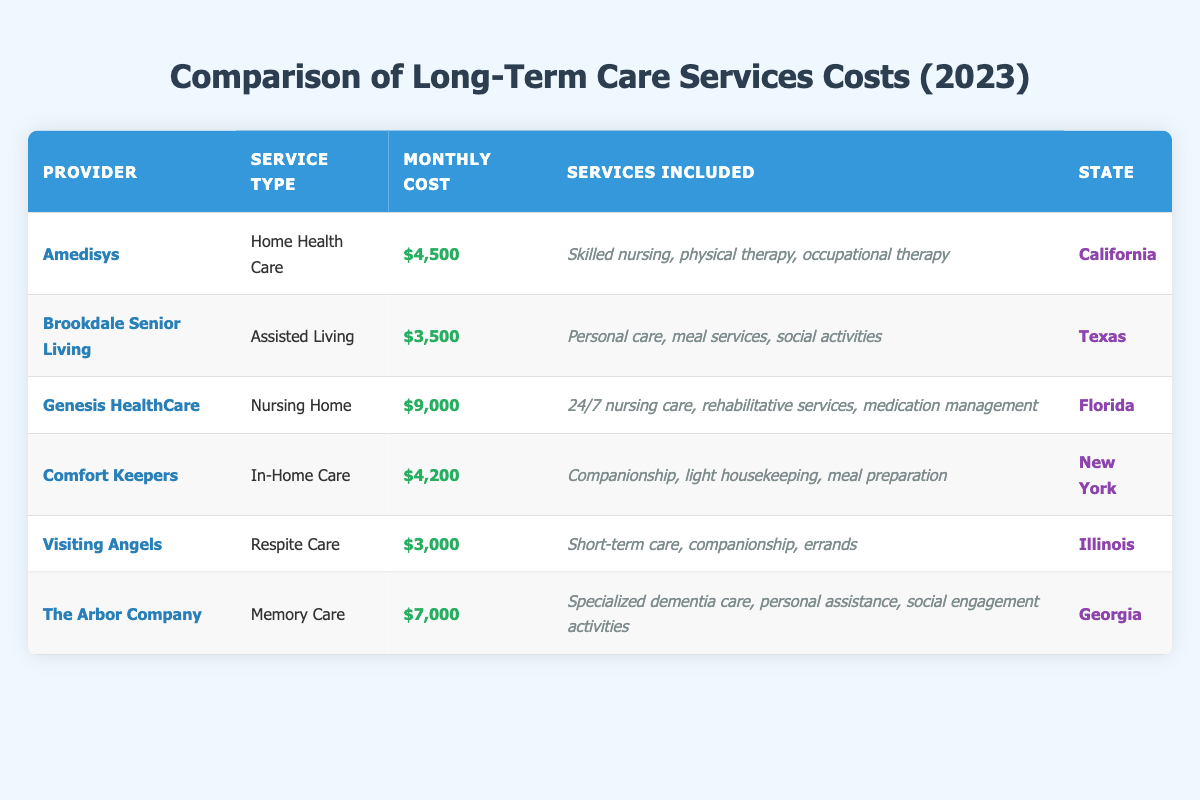What is the highest monthly cost for long-term care services among the providers listed? By reviewing the "Monthly Cost" column, we identify Genesis HealthCare, which has the highest cost of $9,000.
Answer: $9,000 Which provider offers Assisted Living services? According to the "Service Type" column, Brookdale Senior Living is listed as offering Assisted Living services.
Answer: Brookdale Senior Living What is the total monthly cost for In-Home Care and Home Health Care services? To find this, we first extract the costs: In-Home Care (Comfort Keepers) is $4,200 and Home Health Care (Amedisys) is $4,500. Adding these two amounts gives us a total of $4,200 + $4,500 = $8,700.
Answer: $8,700 Is there any provider that offers services in California? Looking at the "State" column, Amedisys offers Home Health Care services in California, confirming that there is a provider in that state.
Answer: Yes What is the average monthly cost of the long-term care services listed? We first sum all the monthly costs: $4,500 (Amedisys) + $3,500 (Brookdale) + $9,000 (Genesis) + $4,200 (Comfort Keepers) + $3,000 (Visiting Angels) + $7,000 (The Arbor Company) = $31,200. Then we divide by the number of providers, which is 6. Thus, the average is $31,200 / 6 = $5,200.
Answer: $5,200 Which provider provides the lowest cost for long-term care services? By inspecting the "Monthly Cost" column, Visiting Angels has the lowest cost of $3,000 among all listed providers.
Answer: Visiting Angels For which service type is the monthly cost $7,000? The table indicates that the Memory Care service type provided by The Arbor Company has a monthly cost of $7,000.
Answer: Memory Care Does Comfort Keepers offer rehabilitation services? Looking at the services included for In-Home Care offered by Comfort Keepers, it does not list rehabilitation services. Therefore, the answer is no.
Answer: No 